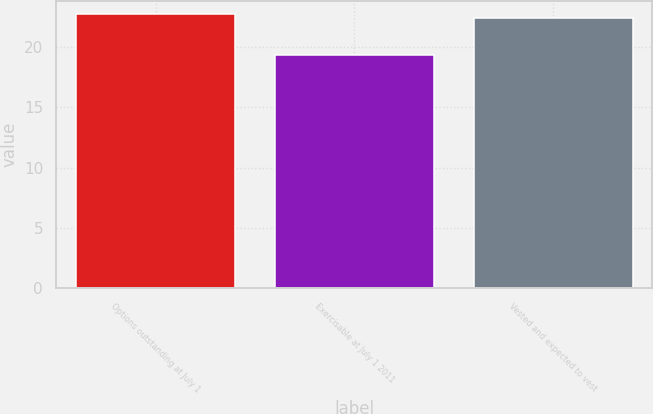Convert chart. <chart><loc_0><loc_0><loc_500><loc_500><bar_chart><fcel>Options outstanding at July 1<fcel>Exercisable at July 1 2011<fcel>Vested and expected to vest<nl><fcel>22.74<fcel>19.36<fcel>22.43<nl></chart> 